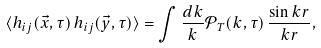Convert formula to latex. <formula><loc_0><loc_0><loc_500><loc_500>\langle h _ { i j } ( \vec { x } , \tau ) \, h _ { i j } ( \vec { y } , \tau ) \rangle = \int \frac { d k } { k } { \mathcal { P } } _ { T } ( k , \tau ) \, \frac { \sin { k r } } { k r } ,</formula> 